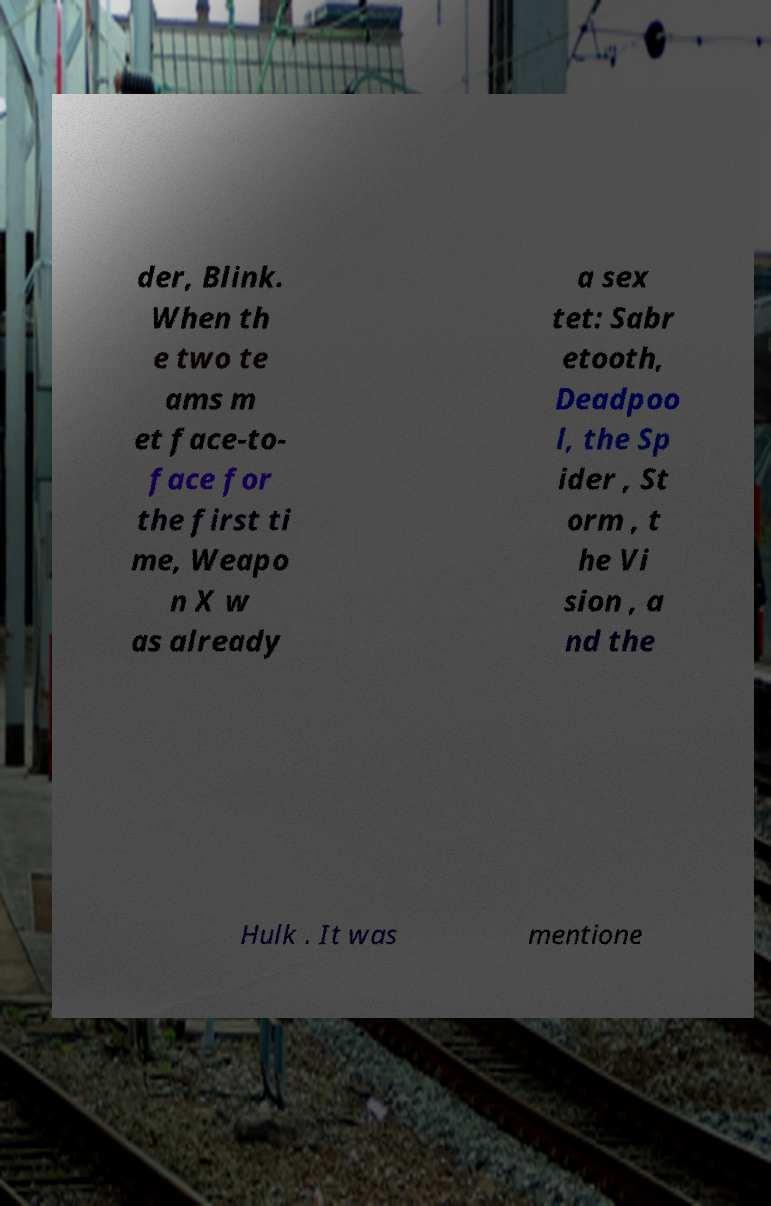There's text embedded in this image that I need extracted. Can you transcribe it verbatim? der, Blink. When th e two te ams m et face-to- face for the first ti me, Weapo n X w as already a sex tet: Sabr etooth, Deadpoo l, the Sp ider , St orm , t he Vi sion , a nd the Hulk . It was mentione 